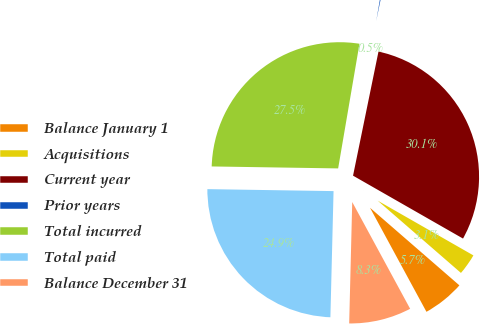Convert chart to OTSL. <chart><loc_0><loc_0><loc_500><loc_500><pie_chart><fcel>Balance January 1<fcel>Acquisitions<fcel>Current year<fcel>Prior years<fcel>Total incurred<fcel>Total paid<fcel>Balance December 31<nl><fcel>5.71%<fcel>3.11%<fcel>30.05%<fcel>0.52%<fcel>27.45%<fcel>24.85%<fcel>8.31%<nl></chart> 